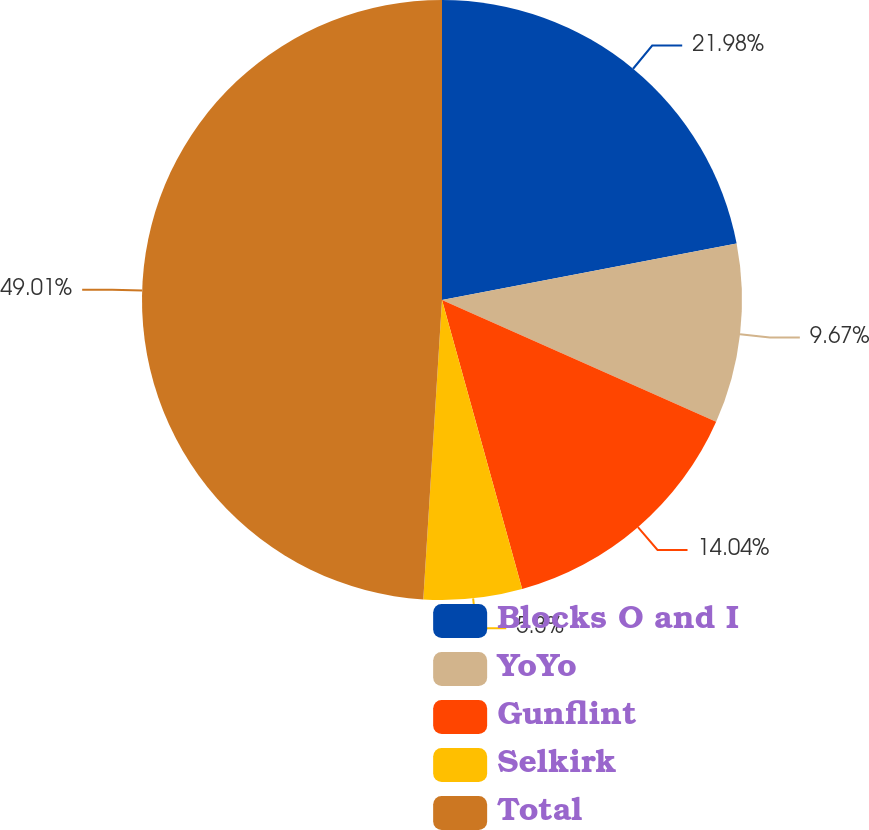Convert chart to OTSL. <chart><loc_0><loc_0><loc_500><loc_500><pie_chart><fcel>Blocks O and I<fcel>YoYo<fcel>Gunflint<fcel>Selkirk<fcel>Total<nl><fcel>21.98%<fcel>9.67%<fcel>14.04%<fcel>5.3%<fcel>49.0%<nl></chart> 